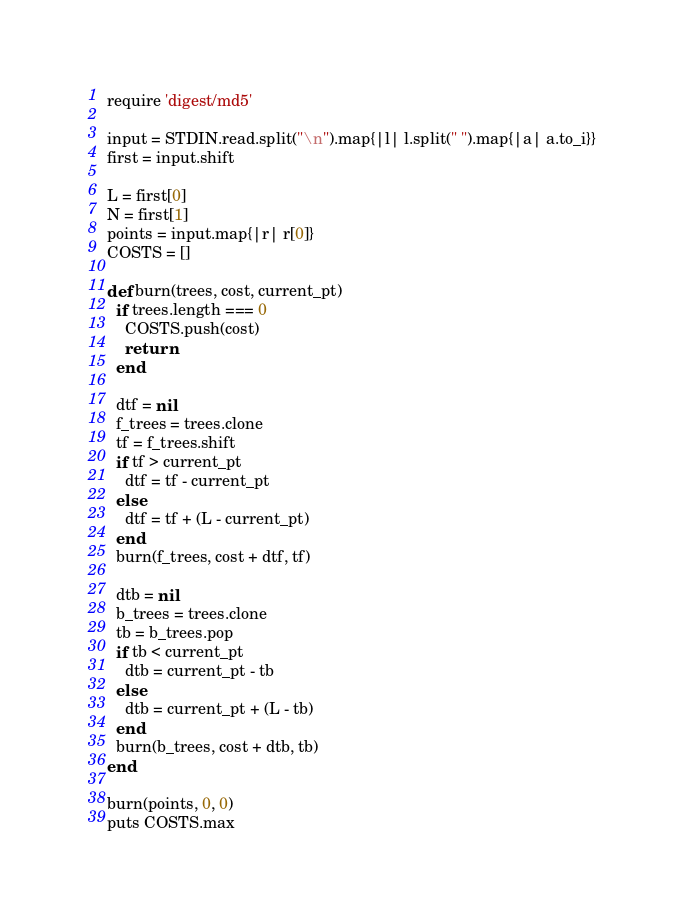Convert code to text. <code><loc_0><loc_0><loc_500><loc_500><_Ruby_>require 'digest/md5'

input = STDIN.read.split("\n").map{|l| l.split(" ").map{|a| a.to_i}}
first = input.shift

L = first[0]
N = first[1]
points = input.map{|r| r[0]}
COSTS = []

def burn(trees, cost, current_pt)
  if trees.length === 0 
    COSTS.push(cost)
    return
  end

  dtf = nil
  f_trees = trees.clone
  tf = f_trees.shift
  if tf > current_pt
    dtf = tf - current_pt
  else
    dtf = tf + (L - current_pt)
  end
  burn(f_trees, cost + dtf, tf)

  dtb = nil
  b_trees = trees.clone
  tb = b_trees.pop
  if tb < current_pt
    dtb = current_pt - tb
  else
    dtb = current_pt + (L - tb)
  end
  burn(b_trees, cost + dtb, tb)
end

burn(points, 0, 0)
puts COSTS.max</code> 